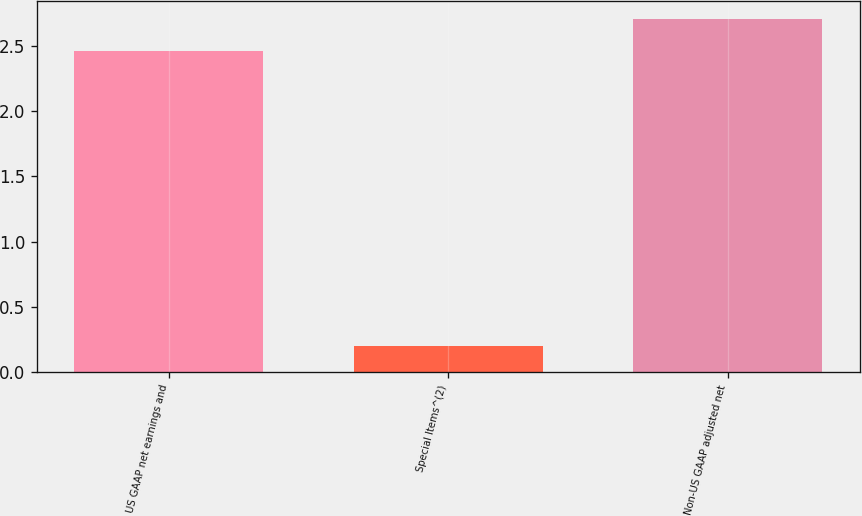Convert chart to OTSL. <chart><loc_0><loc_0><loc_500><loc_500><bar_chart><fcel>US GAAP net earnings and<fcel>Special Items^(2)<fcel>Non-US GAAP adjusted net<nl><fcel>2.46<fcel>0.2<fcel>2.71<nl></chart> 